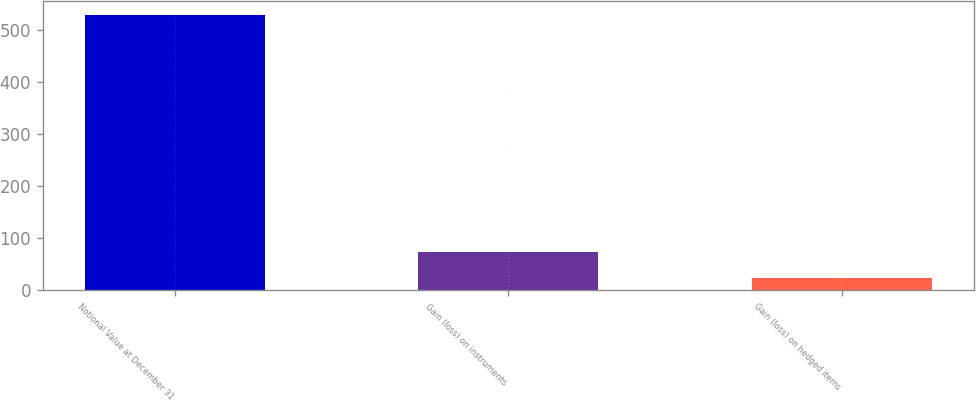<chart> <loc_0><loc_0><loc_500><loc_500><bar_chart><fcel>Notional Value at December 31<fcel>Gain (loss) on instruments<fcel>Gain (loss) on hedged items<nl><fcel>529<fcel>73.6<fcel>23<nl></chart> 